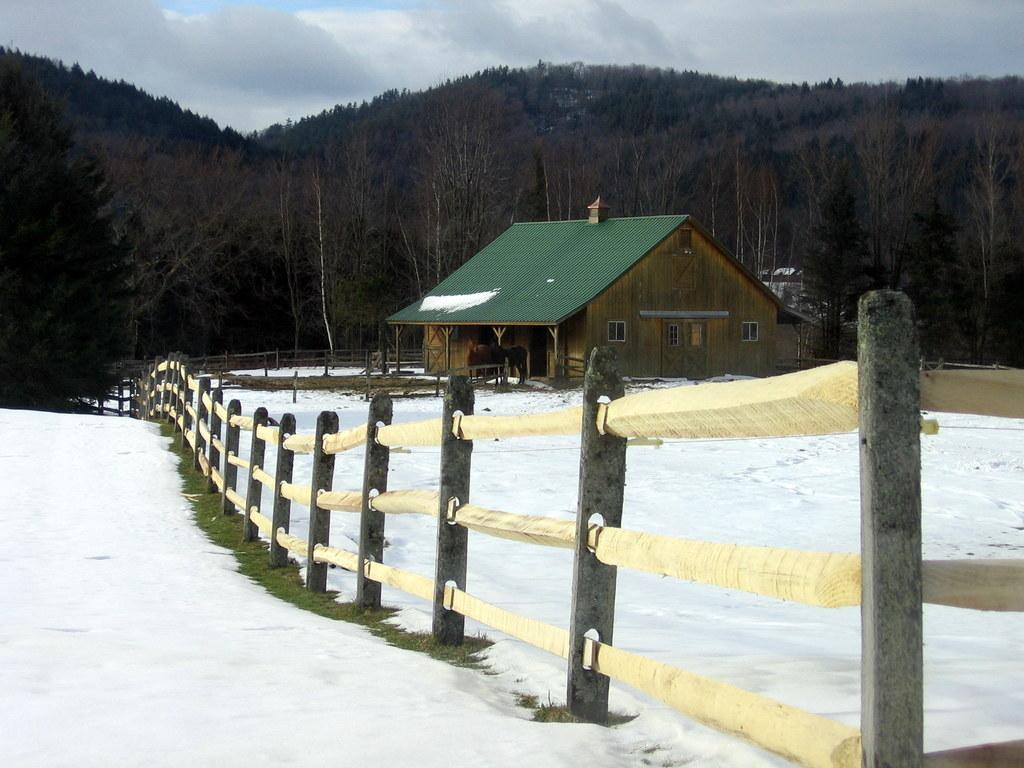What is the condition of the land in the image? The land in the image is covered with snow. What structure is located on the right side of the image? There is a house on the right side of the image. What feature surrounds the house? The house has a fencing around it. What can be seen in the background of the image? There are trees in the background of the image. Where is the baby playing with a hook in the image? There is no baby or hook present in the image. 